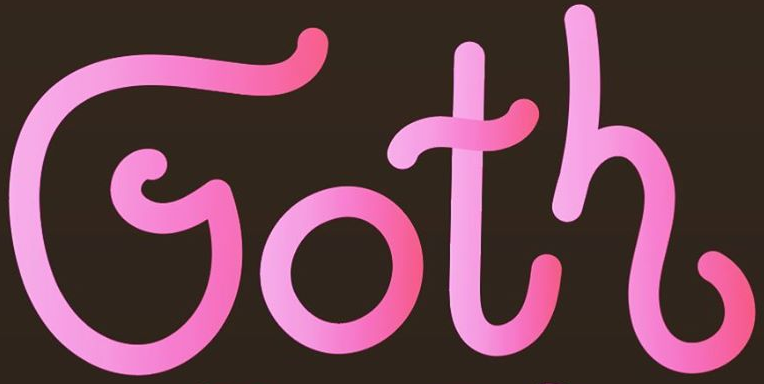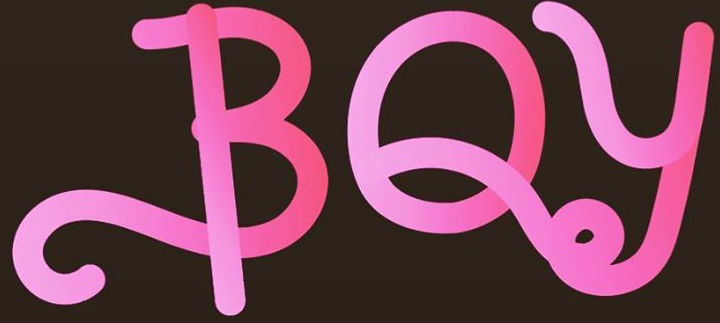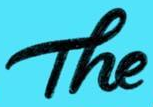What words can you see in these images in sequence, separated by a semicolon? Goth; BOy; The 